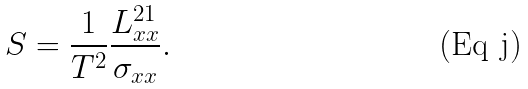Convert formula to latex. <formula><loc_0><loc_0><loc_500><loc_500>S = \frac { 1 } { T ^ { 2 } } \frac { L ^ { 2 1 } _ { x x } } { \sigma _ { x x } } .</formula> 